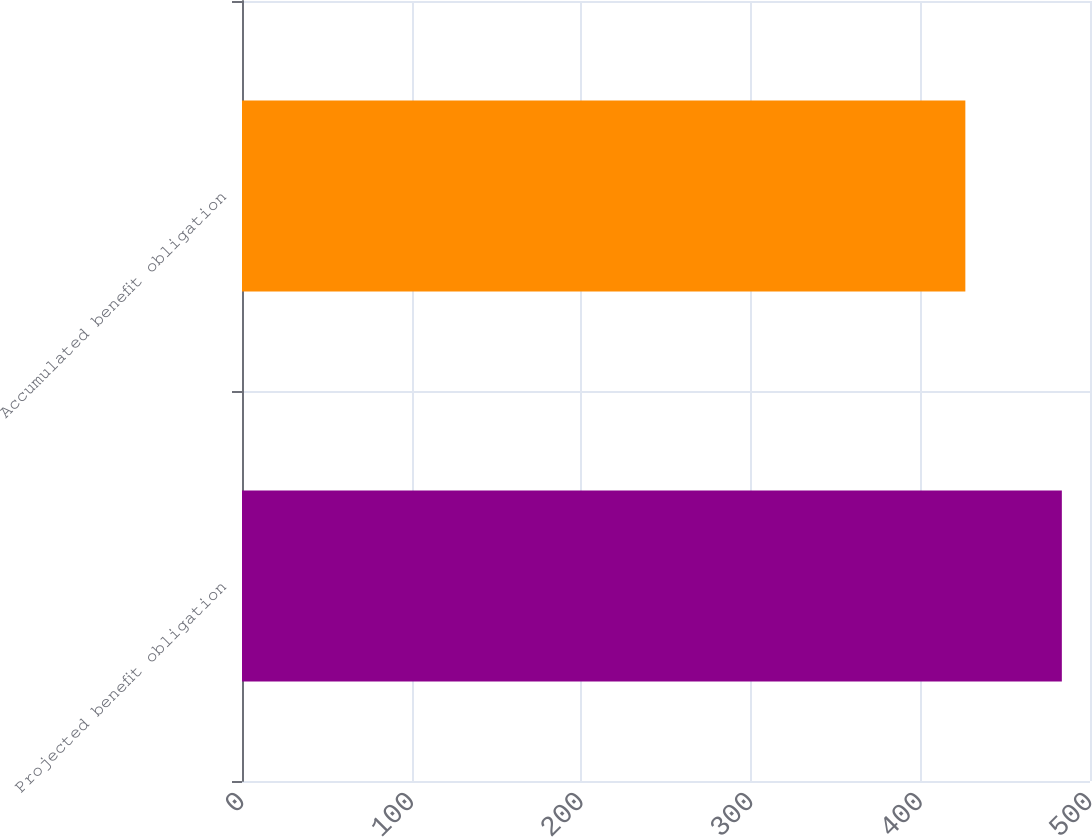Convert chart. <chart><loc_0><loc_0><loc_500><loc_500><bar_chart><fcel>Projected benefit obligation<fcel>Accumulated benefit obligation<nl><fcel>483.4<fcel>426.5<nl></chart> 